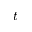<formula> <loc_0><loc_0><loc_500><loc_500>t ^ { - }</formula> 